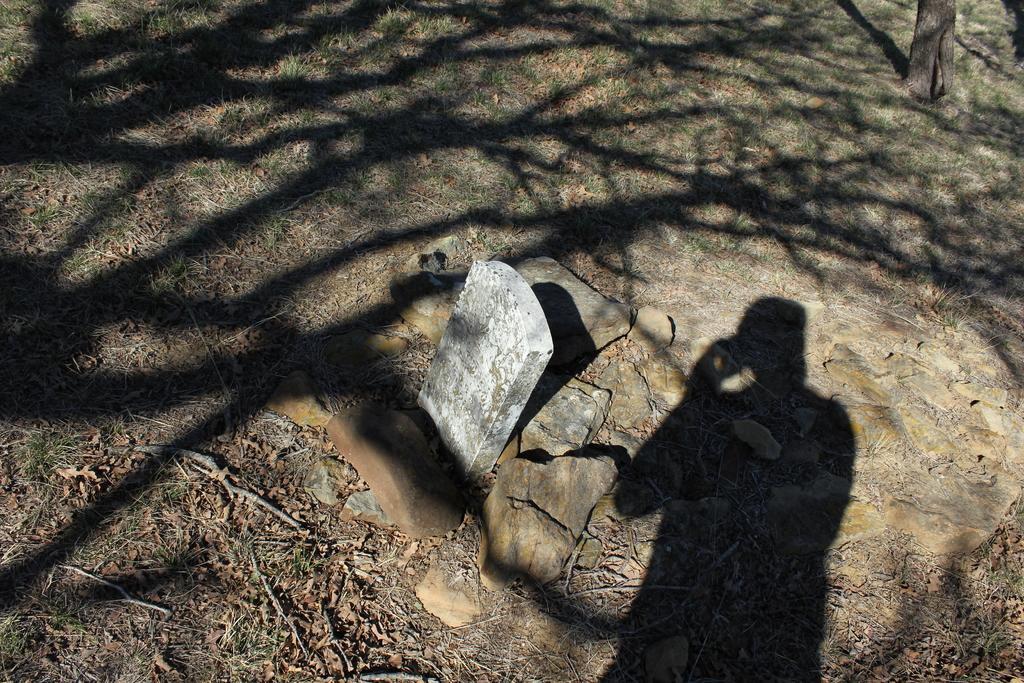Describe this image in one or two sentences. In this image there is a cemetery on the land having few rocks and grass. Right top there is a tree trunk. 